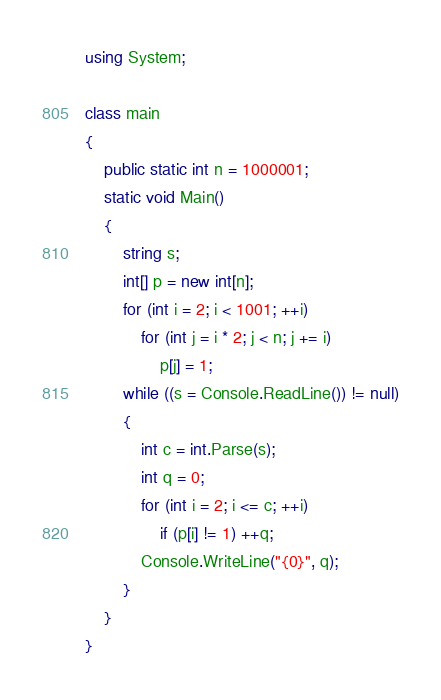<code> <loc_0><loc_0><loc_500><loc_500><_C#_>using System;

class main
{
    public static int n = 1000001;
    static void Main()
    {
        string s;
        int[] p = new int[n];
        for (int i = 2; i < 1001; ++i)
            for (int j = i * 2; j < n; j += i)
                p[j] = 1;
        while ((s = Console.ReadLine()) != null)
        {
            int c = int.Parse(s);
            int q = 0;
            for (int i = 2; i <= c; ++i)
                if (p[i] != 1) ++q;
            Console.WriteLine("{0}", q);
        }
    }
}</code> 